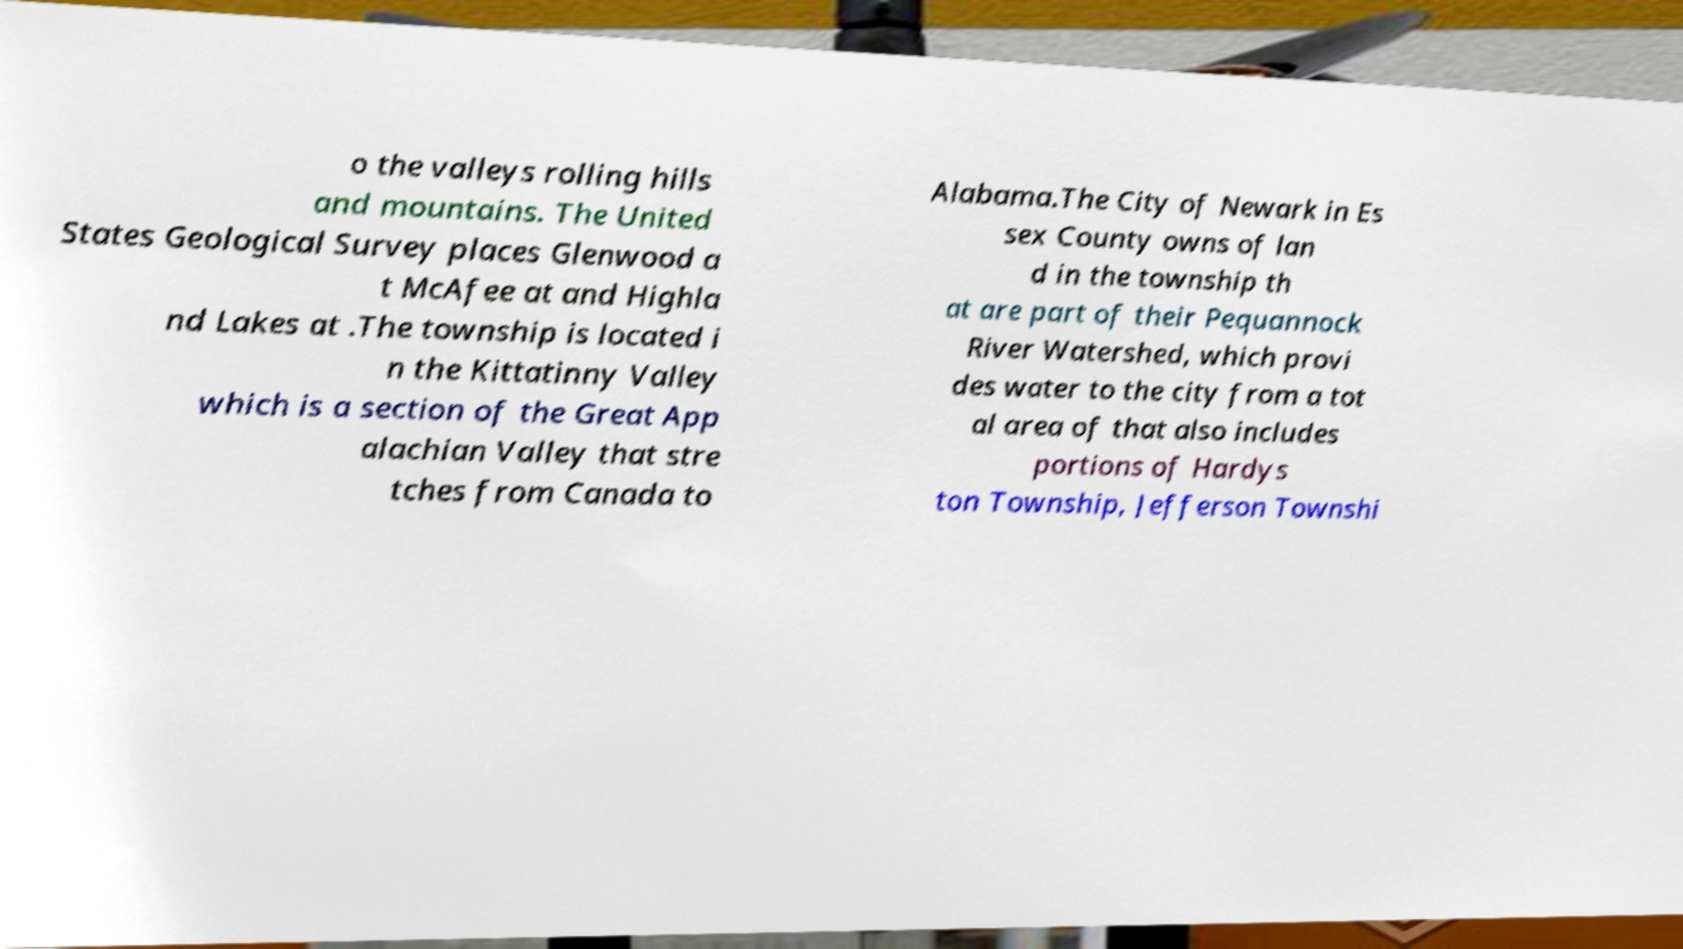I need the written content from this picture converted into text. Can you do that? o the valleys rolling hills and mountains. The United States Geological Survey places Glenwood a t McAfee at and Highla nd Lakes at .The township is located i n the Kittatinny Valley which is a section of the Great App alachian Valley that stre tches from Canada to Alabama.The City of Newark in Es sex County owns of lan d in the township th at are part of their Pequannock River Watershed, which provi des water to the city from a tot al area of that also includes portions of Hardys ton Township, Jefferson Townshi 